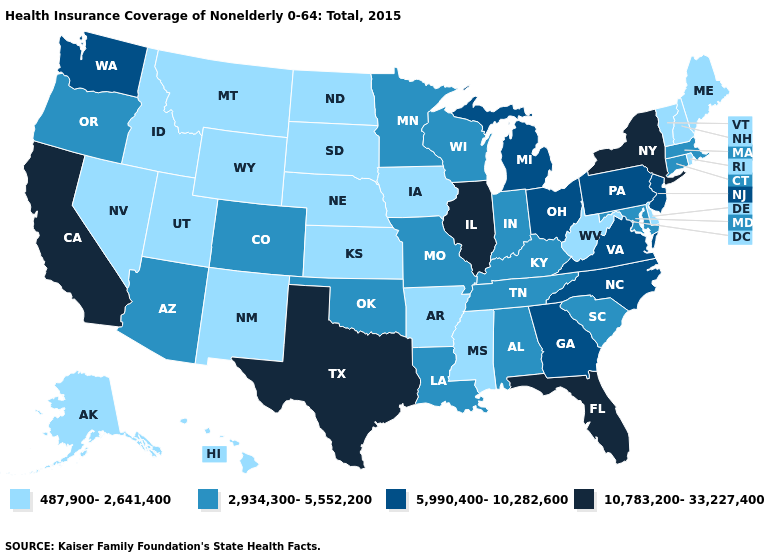Does Rhode Island have the same value as Nebraska?
Give a very brief answer. Yes. Is the legend a continuous bar?
Short answer required. No. Which states have the highest value in the USA?
Concise answer only. California, Florida, Illinois, New York, Texas. Does Pennsylvania have the same value as West Virginia?
Concise answer only. No. What is the value of Washington?
Answer briefly. 5,990,400-10,282,600. Name the states that have a value in the range 10,783,200-33,227,400?
Write a very short answer. California, Florida, Illinois, New York, Texas. Which states have the lowest value in the West?
Keep it brief. Alaska, Hawaii, Idaho, Montana, Nevada, New Mexico, Utah, Wyoming. Name the states that have a value in the range 5,990,400-10,282,600?
Quick response, please. Georgia, Michigan, New Jersey, North Carolina, Ohio, Pennsylvania, Virginia, Washington. What is the value of Minnesota?
Keep it brief. 2,934,300-5,552,200. What is the value of New Jersey?
Concise answer only. 5,990,400-10,282,600. Among the states that border Pennsylvania , which have the highest value?
Write a very short answer. New York. Does Ohio have the lowest value in the MidWest?
Answer briefly. No. Is the legend a continuous bar?
Answer briefly. No. What is the highest value in the USA?
Answer briefly. 10,783,200-33,227,400. Does the first symbol in the legend represent the smallest category?
Give a very brief answer. Yes. 